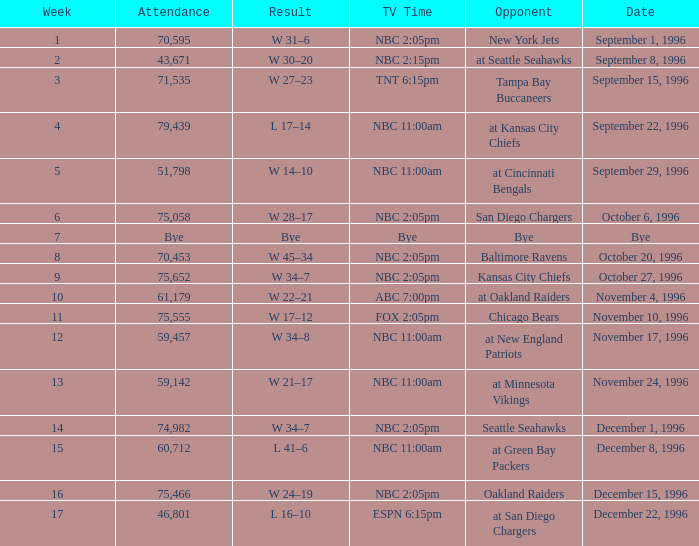WHAT IS THE RESULT WHEN THE OPPONENT WAS CHICAGO BEARS? W 17–12. 